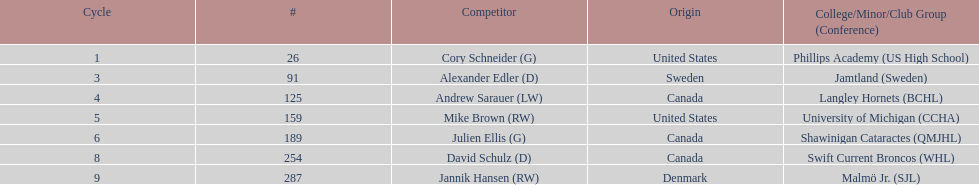The first round not to have a draft pick. 2. 